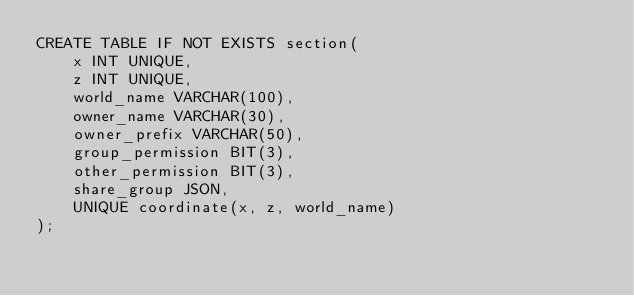Convert code to text. <code><loc_0><loc_0><loc_500><loc_500><_SQL_>CREATE TABLE IF NOT EXISTS section(
    x INT UNIQUE,
    z INT UNIQUE,
    world_name VARCHAR(100),
    owner_name VARCHAR(30),
    owner_prefix VARCHAR(50),
    group_permission BIT(3),
    other_permission BIT(3),
    share_group JSON,
    UNIQUE coordinate(x, z, world_name)
);</code> 